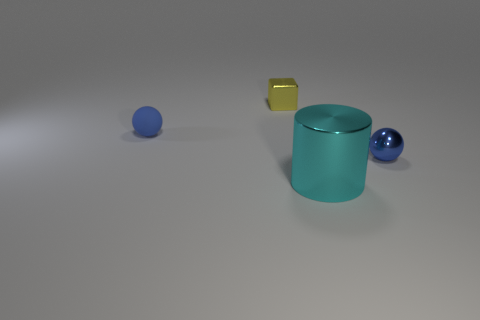There is a big cyan metallic thing; how many blue shiny spheres are in front of it?
Ensure brevity in your answer.  0. What material is the large cyan thing?
Offer a very short reply. Metal. What is the color of the ball that is in front of the small blue object that is on the left side of the tiny thing on the right side of the tiny block?
Give a very brief answer. Blue. What number of other cubes are the same size as the yellow cube?
Your answer should be compact. 0. There is a metal thing that is right of the shiny cylinder; what color is it?
Offer a terse response. Blue. What number of other objects are there of the same size as the shiny cylinder?
Your response must be concise. 0. How big is the thing that is both right of the small matte sphere and on the left side of the large shiny cylinder?
Provide a short and direct response. Small. Does the shiny block have the same color as the small metal thing in front of the tiny yellow metal block?
Keep it short and to the point. No. Is there a brown matte thing of the same shape as the blue matte thing?
Your response must be concise. No. How many things are either small yellow matte blocks or blue spheres to the left of the small yellow object?
Provide a succinct answer. 1. 